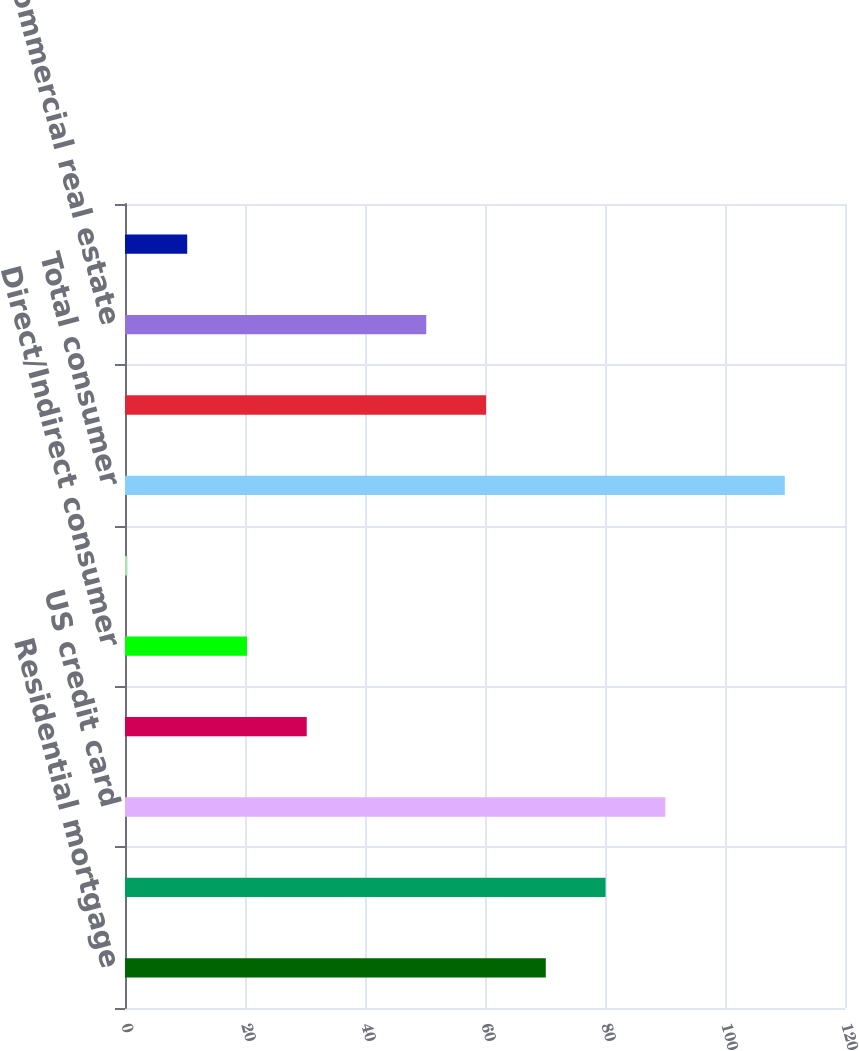Convert chart. <chart><loc_0><loc_0><loc_500><loc_500><bar_chart><fcel>Residential mortgage<fcel>Home equity<fcel>US credit card<fcel>Non-US credit card<fcel>Direct/Indirect consumer<fcel>Other consumer<fcel>Total consumer<fcel>US commercial (1)<fcel>Commercial real estate<fcel>Commercial lease financing<nl><fcel>70.13<fcel>80.09<fcel>90.05<fcel>30.29<fcel>20.33<fcel>0.41<fcel>109.97<fcel>60.17<fcel>50.21<fcel>10.37<nl></chart> 